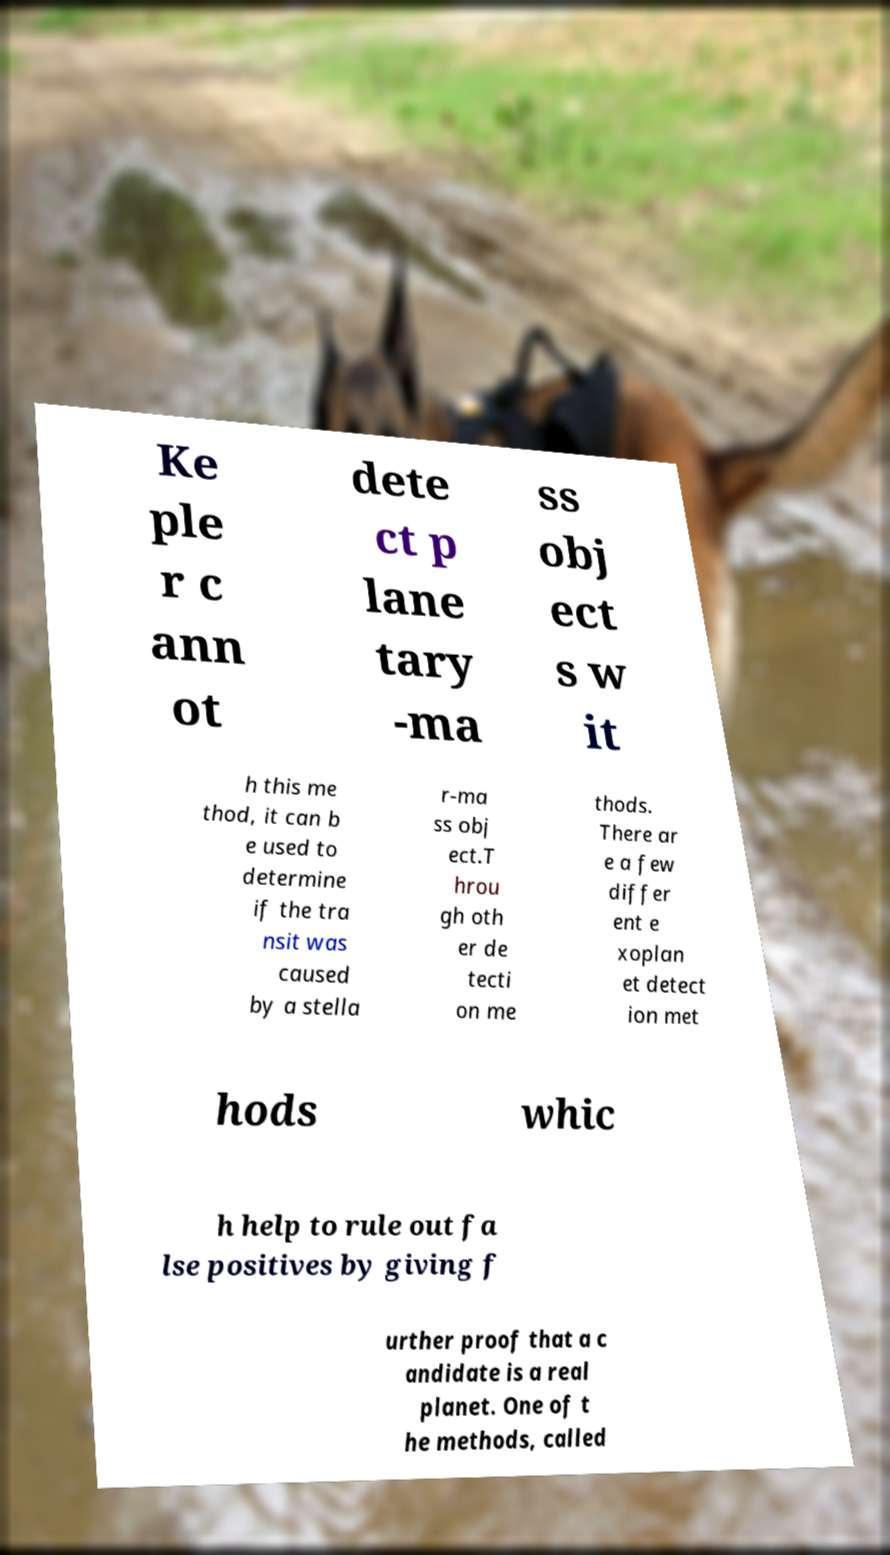Please read and relay the text visible in this image. What does it say? Ke ple r c ann ot dete ct p lane tary -ma ss obj ect s w it h this me thod, it can b e used to determine if the tra nsit was caused by a stella r-ma ss obj ect.T hrou gh oth er de tecti on me thods. There ar e a few differ ent e xoplan et detect ion met hods whic h help to rule out fa lse positives by giving f urther proof that a c andidate is a real planet. One of t he methods, called 